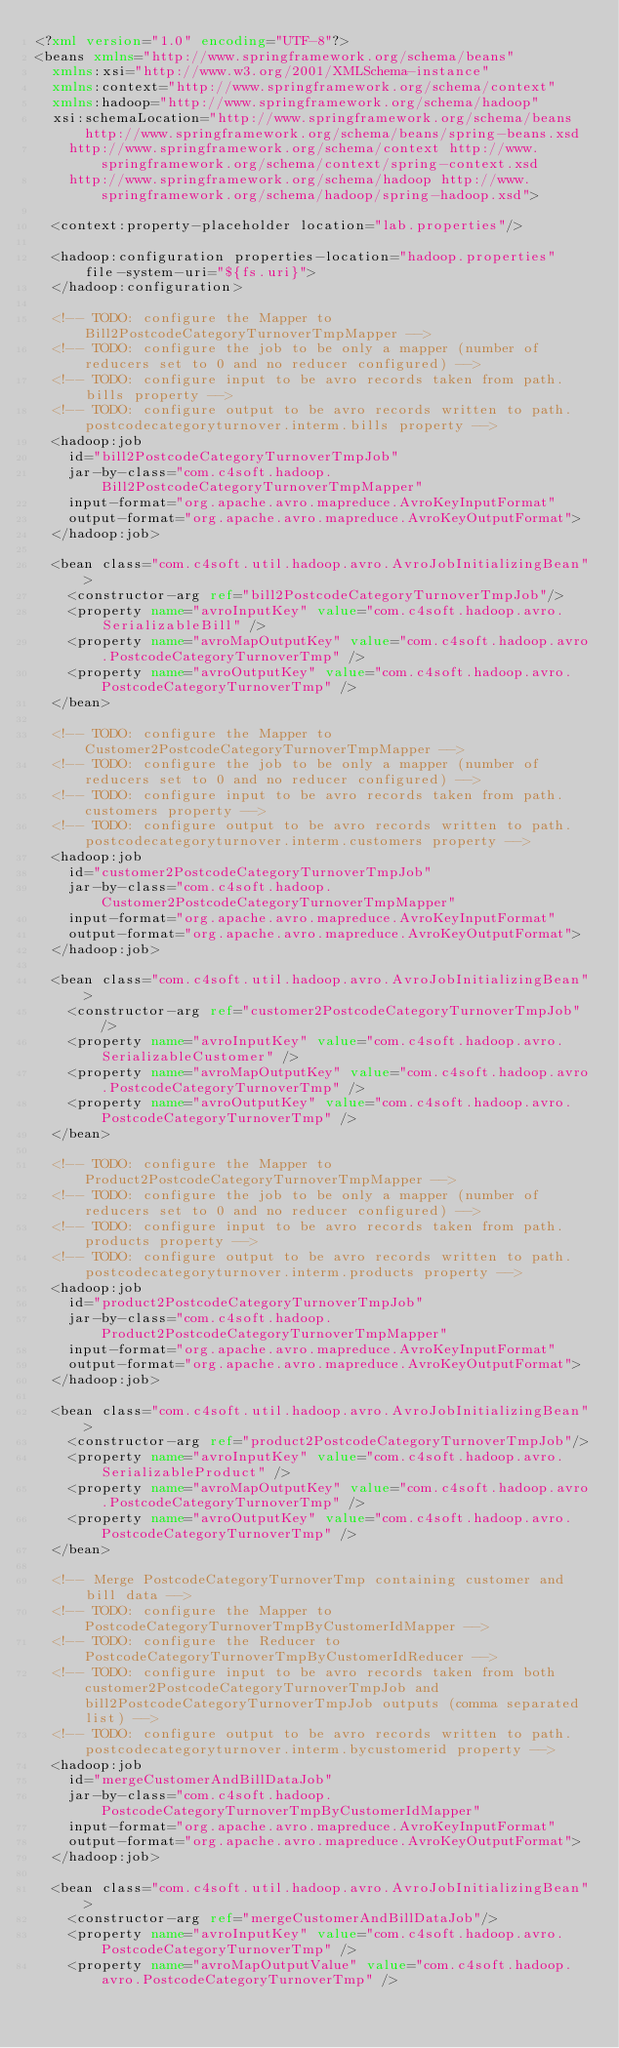Convert code to text. <code><loc_0><loc_0><loc_500><loc_500><_XML_><?xml version="1.0" encoding="UTF-8"?>
<beans xmlns="http://www.springframework.org/schema/beans"
	xmlns:xsi="http://www.w3.org/2001/XMLSchema-instance"
	xmlns:context="http://www.springframework.org/schema/context"
	xmlns:hadoop="http://www.springframework.org/schema/hadoop"
	xsi:schemaLocation="http://www.springframework.org/schema/beans http://www.springframework.org/schema/beans/spring-beans.xsd
		http://www.springframework.org/schema/context http://www.springframework.org/schema/context/spring-context.xsd
		http://www.springframework.org/schema/hadoop http://www.springframework.org/schema/hadoop/spring-hadoop.xsd">

	<context:property-placeholder location="lab.properties"/>

	<hadoop:configuration properties-location="hadoop.properties" file-system-uri="${fs.uri}">
	</hadoop:configuration>

	<!-- TODO: configure the Mapper to Bill2PostcodeCategoryTurnoverTmpMapper -->
	<!-- TODO: configure the job to be only a mapper (number of reducers set to 0 and no reducer configured) -->
	<!-- TODO: configure input to be avro records taken from path.bills property -->
	<!-- TODO: configure output to be avro records written to path.postcodecategoryturnover.interm.bills property -->
	<hadoop:job
		id="bill2PostcodeCategoryTurnoverTmpJob"
		jar-by-class="com.c4soft.hadoop.Bill2PostcodeCategoryTurnoverTmpMapper"
		input-format="org.apache.avro.mapreduce.AvroKeyInputFormat"
		output-format="org.apache.avro.mapreduce.AvroKeyOutputFormat">
	</hadoop:job>
	
	<bean class="com.c4soft.util.hadoop.avro.AvroJobInitializingBean">
		<constructor-arg ref="bill2PostcodeCategoryTurnoverTmpJob"/>
		<property name="avroInputKey" value="com.c4soft.hadoop.avro.SerializableBill" />
		<property name="avroMapOutputKey" value="com.c4soft.hadoop.avro.PostcodeCategoryTurnoverTmp" />
		<property name="avroOutputKey" value="com.c4soft.hadoop.avro.PostcodeCategoryTurnoverTmp" />
	</bean>

	<!-- TODO: configure the Mapper to Customer2PostcodeCategoryTurnoverTmpMapper -->
	<!-- TODO: configure the job to be only a mapper (number of reducers set to 0 and no reducer configured) -->
	<!-- TODO: configure input to be avro records taken from path.customers property -->
	<!-- TODO: configure output to be avro records written to path.postcodecategoryturnover.interm.customers property -->
	<hadoop:job
		id="customer2PostcodeCategoryTurnoverTmpJob"
		jar-by-class="com.c4soft.hadoop.Customer2PostcodeCategoryTurnoverTmpMapper"
		input-format="org.apache.avro.mapreduce.AvroKeyInputFormat"
		output-format="org.apache.avro.mapreduce.AvroKeyOutputFormat">
	</hadoop:job>
	
	<bean class="com.c4soft.util.hadoop.avro.AvroJobInitializingBean">
		<constructor-arg ref="customer2PostcodeCategoryTurnoverTmpJob"/>
		<property name="avroInputKey" value="com.c4soft.hadoop.avro.SerializableCustomer" />
		<property name="avroMapOutputKey" value="com.c4soft.hadoop.avro.PostcodeCategoryTurnoverTmp" />
		<property name="avroOutputKey" value="com.c4soft.hadoop.avro.PostcodeCategoryTurnoverTmp" />
	</bean>

	<!-- TODO: configure the Mapper to Product2PostcodeCategoryTurnoverTmpMapper -->
	<!-- TODO: configure the job to be only a mapper (number of reducers set to 0 and no reducer configured) -->
	<!-- TODO: configure input to be avro records taken from path.products property -->
	<!-- TODO: configure output to be avro records written to path.postcodecategoryturnover.interm.products property -->
	<hadoop:job
		id="product2PostcodeCategoryTurnoverTmpJob"
		jar-by-class="com.c4soft.hadoop.Product2PostcodeCategoryTurnoverTmpMapper"
		input-format="org.apache.avro.mapreduce.AvroKeyInputFormat"
		output-format="org.apache.avro.mapreduce.AvroKeyOutputFormat">
	</hadoop:job>
	
	<bean class="com.c4soft.util.hadoop.avro.AvroJobInitializingBean">
		<constructor-arg ref="product2PostcodeCategoryTurnoverTmpJob"/>
		<property name="avroInputKey" value="com.c4soft.hadoop.avro.SerializableProduct" />
		<property name="avroMapOutputKey" value="com.c4soft.hadoop.avro.PostcodeCategoryTurnoverTmp" />
		<property name="avroOutputKey" value="com.c4soft.hadoop.avro.PostcodeCategoryTurnoverTmp" />
	</bean>

	<!-- Merge PostcodeCategoryTurnoverTmp containing customer and bill data -->
	<!-- TODO: configure the Mapper to PostcodeCategoryTurnoverTmpByCustomerIdMapper -->
	<!-- TODO: configure the Reducer to PostcodeCategoryTurnoverTmpByCustomerIdReducer -->
	<!-- TODO: configure input to be avro records taken from both customer2PostcodeCategoryTurnoverTmpJob and bill2PostcodeCategoryTurnoverTmpJob outputs (comma separated list) -->
	<!-- TODO: configure output to be avro records written to path.postcodecategoryturnover.interm.bycustomerid property -->
	<hadoop:job
		id="mergeCustomerAndBillDataJob"
		jar-by-class="com.c4soft.hadoop.PostcodeCategoryTurnoverTmpByCustomerIdMapper"
		input-format="org.apache.avro.mapreduce.AvroKeyInputFormat"
		output-format="org.apache.avro.mapreduce.AvroKeyOutputFormat">
	</hadoop:job>
	
	<bean class="com.c4soft.util.hadoop.avro.AvroJobInitializingBean">
		<constructor-arg ref="mergeCustomerAndBillDataJob"/>
		<property name="avroInputKey" value="com.c4soft.hadoop.avro.PostcodeCategoryTurnoverTmp" />
		<property name="avroMapOutputValue" value="com.c4soft.hadoop.avro.PostcodeCategoryTurnoverTmp" /></code> 